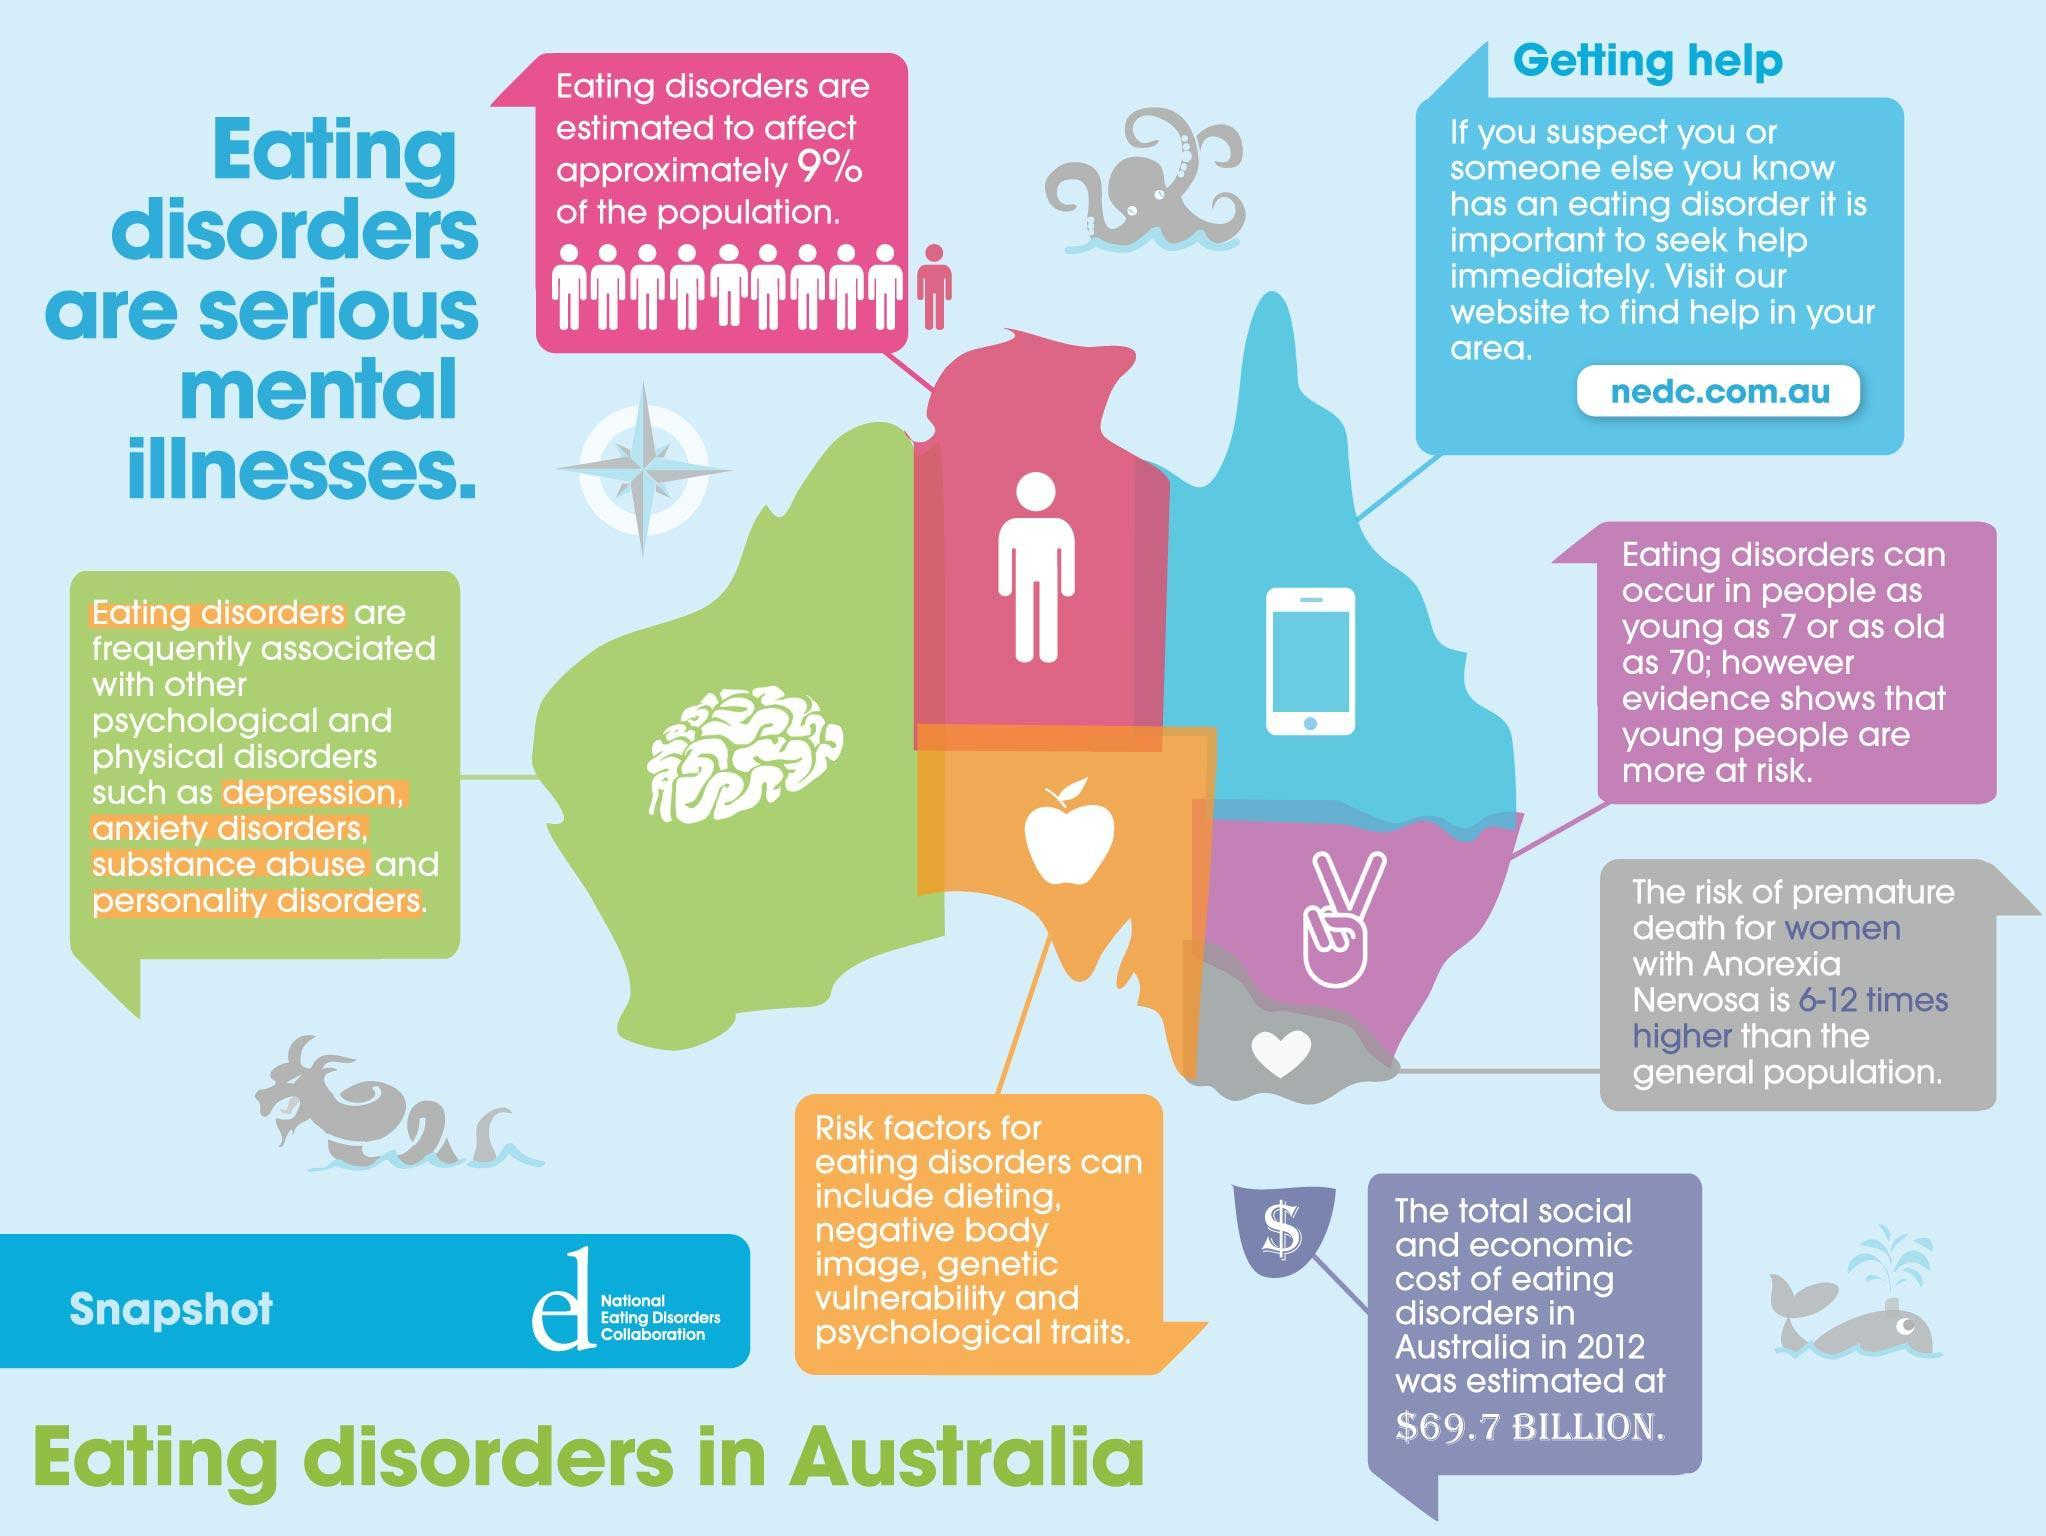How much of the population are affected by eating disorders?
Answer the question with a short phrase. 9% People with which condition are at 6-12 times higher risk of premature death? Anorexia Nervosa What should be done if you know someone has an eating disorder? seek help immediately what can occur in people of any age from 7 to 70? eating disorders negative body image and dieting are associated with which disorder? eating disorders What was the 2012 total social and economic cost of eating disorders? $69.7 Billion What is associated with psychological disorders like depression, anxiety disorders etc. ? eating disorders 